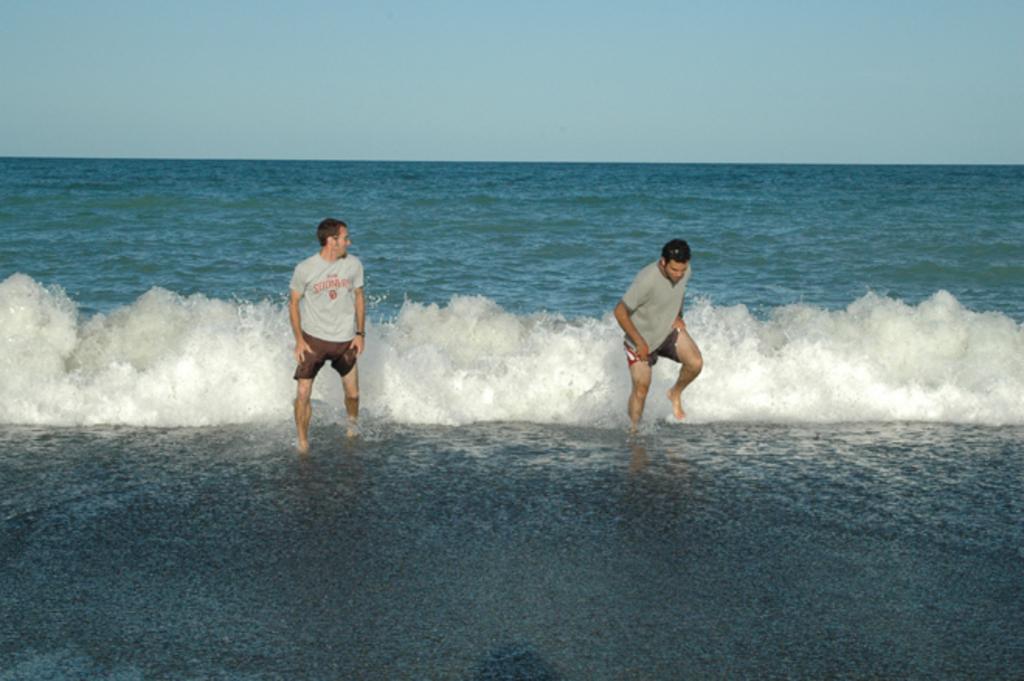Can you describe this image briefly? In this image we can see two people in the water, in the background we can see the sky. 